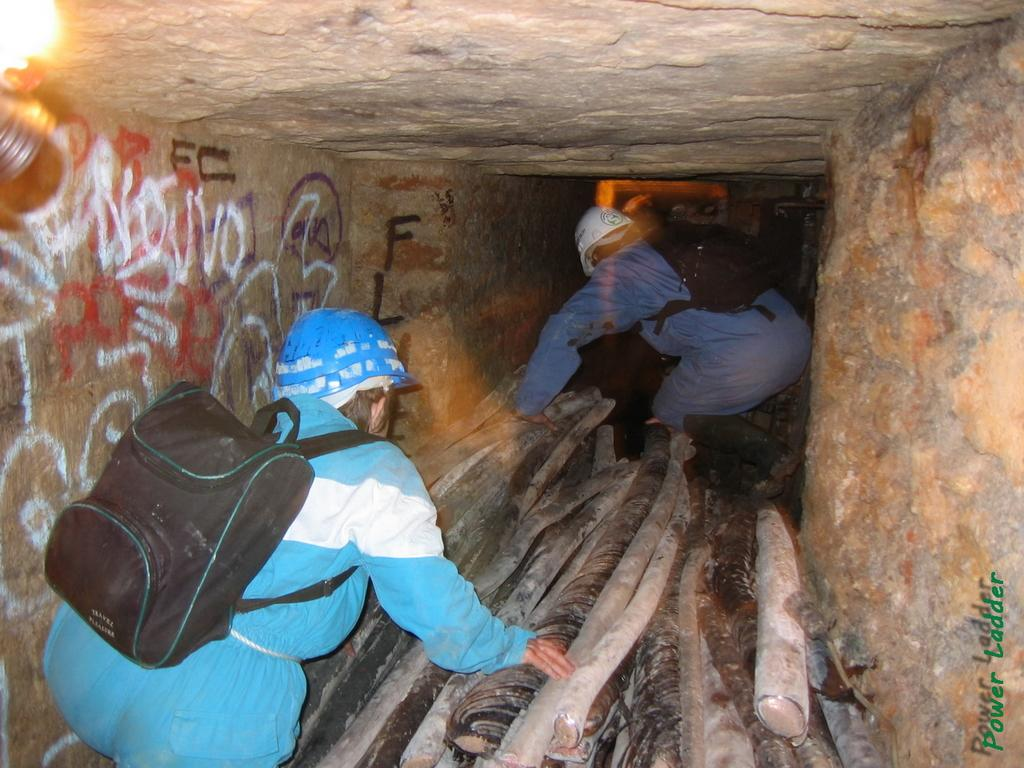How many people are present in the image? There are two persons in the image. What are the persons doing in the image? The persons are working in a tunnel. Can you describe any objects present in the image? There are wooden sticks in the image. What type of mint can be seen growing in the image? There is no mint present in the image; it features two persons working in a tunnel with wooden sticks. 